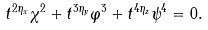Convert formula to latex. <formula><loc_0><loc_0><loc_500><loc_500>t ^ { 2 \eta _ { x } } \chi ^ { 2 } + t ^ { 3 \eta _ { y } } \varphi ^ { 3 } + t ^ { 4 \eta _ { z } } \psi ^ { 4 } = 0 . \\</formula> 